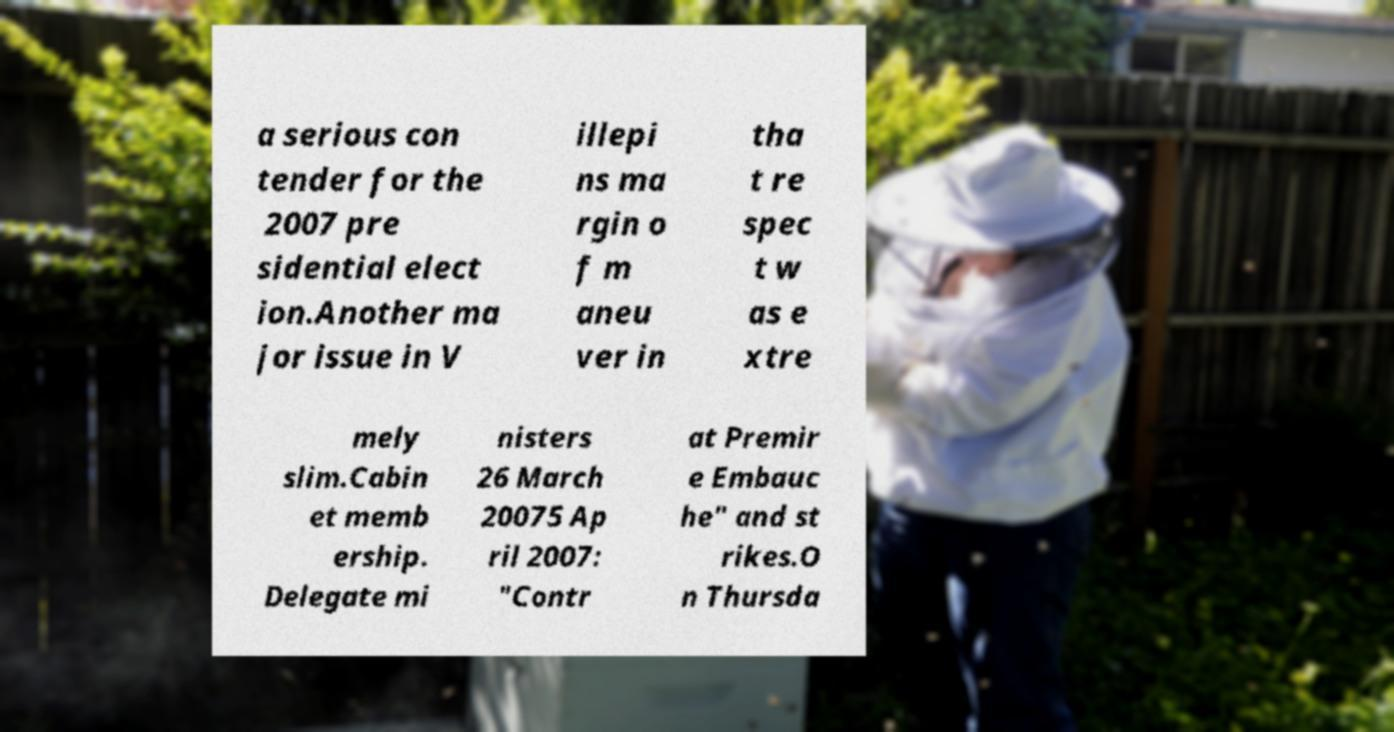For documentation purposes, I need the text within this image transcribed. Could you provide that? a serious con tender for the 2007 pre sidential elect ion.Another ma jor issue in V illepi ns ma rgin o f m aneu ver in tha t re spec t w as e xtre mely slim.Cabin et memb ership. Delegate mi nisters 26 March 20075 Ap ril 2007: "Contr at Premir e Embauc he" and st rikes.O n Thursda 